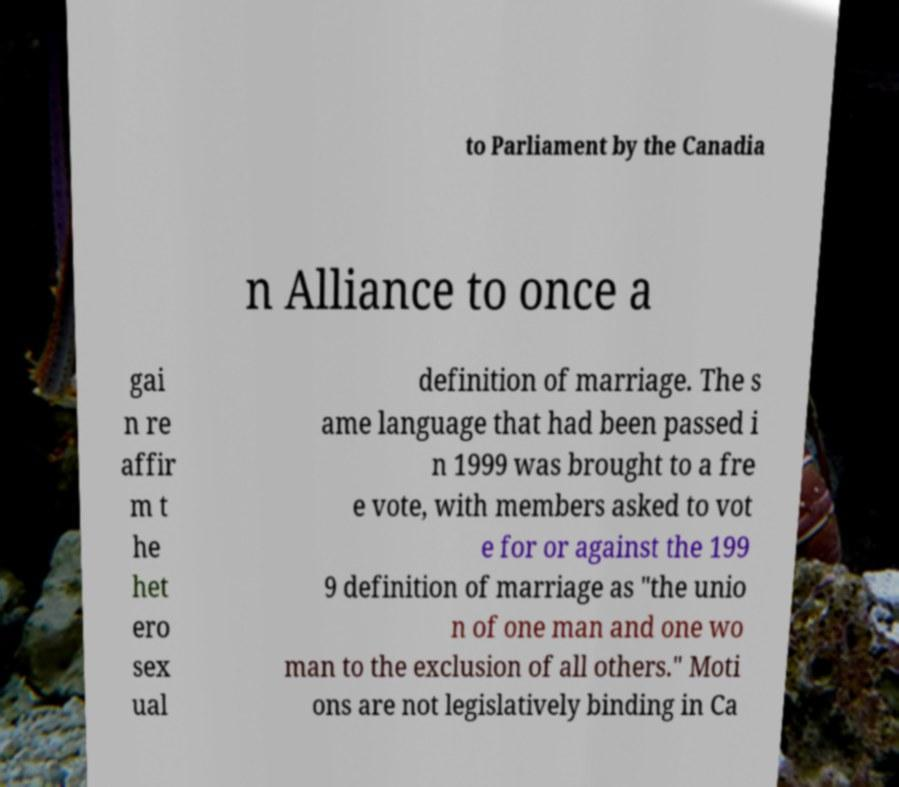Could you extract and type out the text from this image? to Parliament by the Canadia n Alliance to once a gai n re affir m t he het ero sex ual definition of marriage. The s ame language that had been passed i n 1999 was brought to a fre e vote, with members asked to vot e for or against the 199 9 definition of marriage as "the unio n of one man and one wo man to the exclusion of all others." Moti ons are not legislatively binding in Ca 